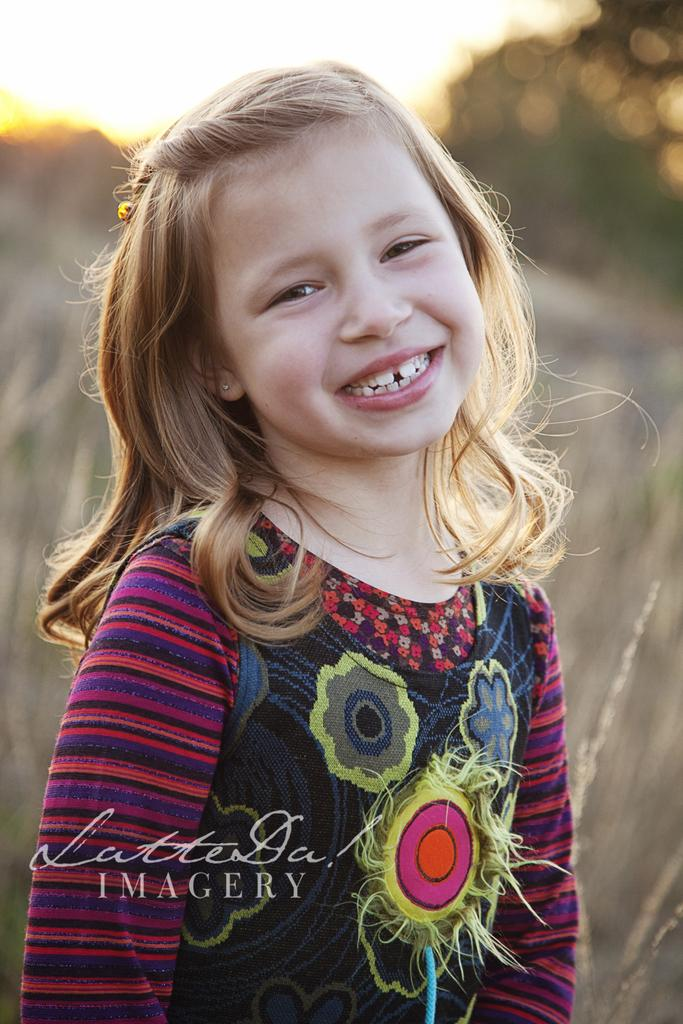What is the main subject of the image? There is a kid in the center of the image. What is the kid's expression in the image? The kid is smiling. What can be seen on the left side of the image? There is a watermark on the left side of the image. What is visible in the background of the image? The sky, trees, and grass are visible in the background of the image. What type of fish is swimming in the background of the image? There are no fish present in the image; it features a kid in the foreground with a background of sky, trees, and grass. Can you provide any expert advice on the subject matter of the image? The image is a simple photograph of a smiling kid, and no expert advice is necessary to understand or appreciate it. 